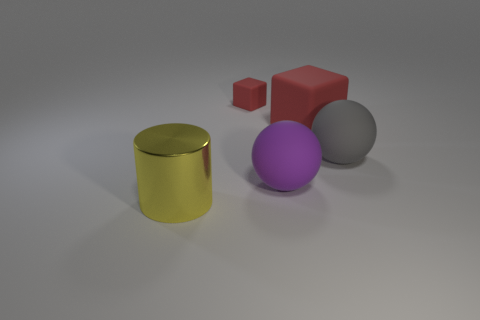What could be the purpose of these objects together? These objects could be used as part of a visual presentation or exhibit to demonstrate various geometric shapes, sizes, and colors, and to compare and contrast their properties such as volume, surface area, and reflective qualities. Are these objects commonly found together? Not typically. They seem to be more of an abstract arrangement for artistic or educational purposes rather than objects that would be functionally grouped together in a real-world context. 